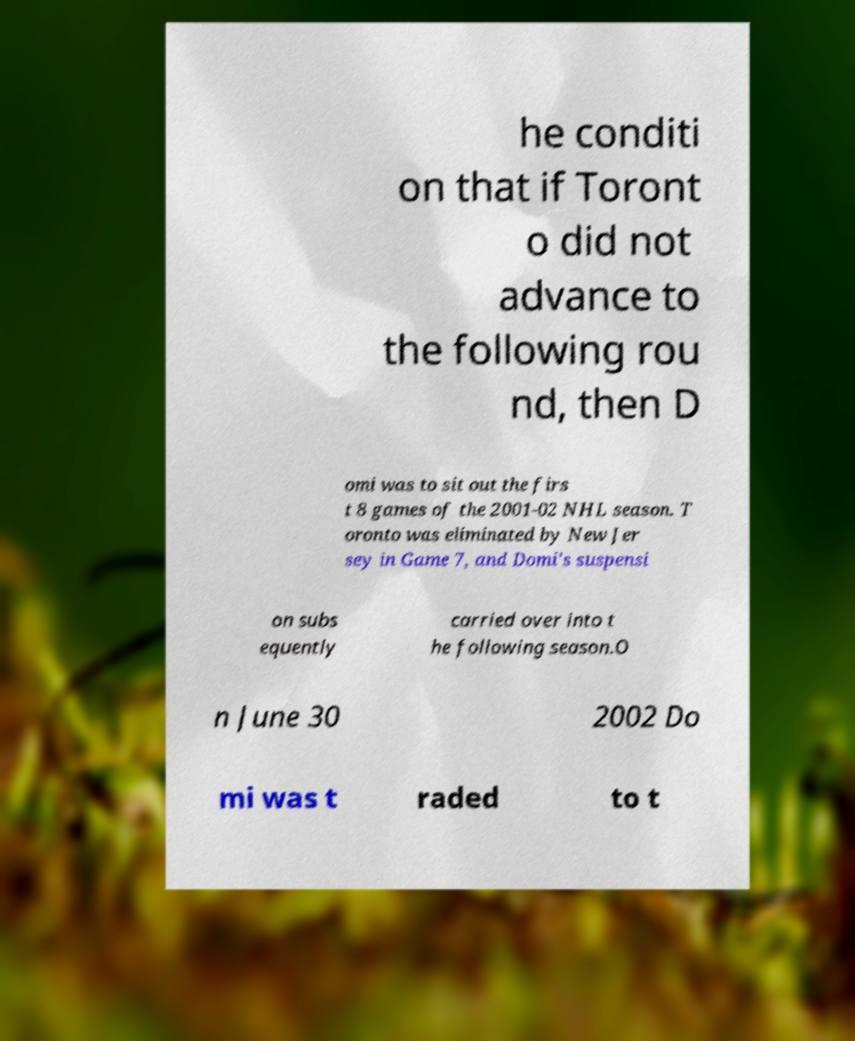Could you extract and type out the text from this image? he conditi on that if Toront o did not advance to the following rou nd, then D omi was to sit out the firs t 8 games of the 2001-02 NHL season. T oronto was eliminated by New Jer sey in Game 7, and Domi's suspensi on subs equently carried over into t he following season.O n June 30 2002 Do mi was t raded to t 